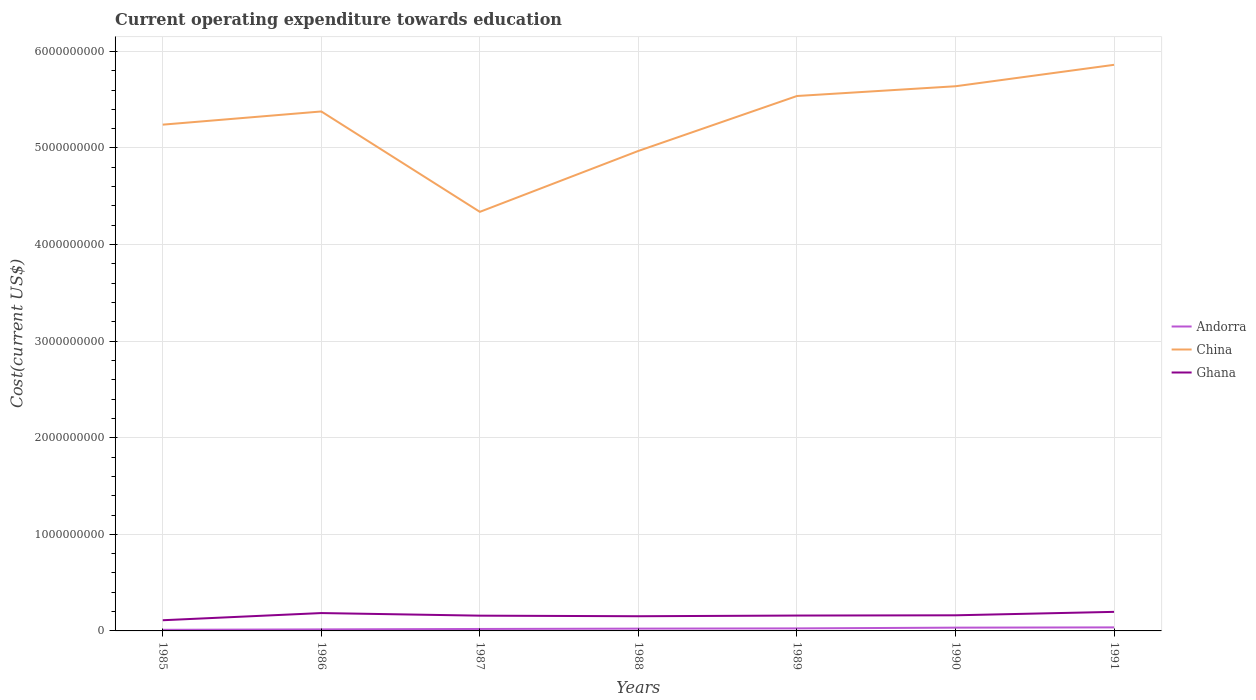Across all years, what is the maximum expenditure towards education in Ghana?
Your answer should be compact. 1.11e+08. What is the total expenditure towards education in Ghana in the graph?
Your answer should be very brief. -7.15e+06. What is the difference between the highest and the second highest expenditure towards education in China?
Make the answer very short. 1.52e+09. What is the difference between the highest and the lowest expenditure towards education in Andorra?
Your answer should be very brief. 3. How many lines are there?
Offer a terse response. 3. How many years are there in the graph?
Give a very brief answer. 7. What is the difference between two consecutive major ticks on the Y-axis?
Your answer should be compact. 1.00e+09. Are the values on the major ticks of Y-axis written in scientific E-notation?
Make the answer very short. No. Does the graph contain grids?
Your answer should be compact. Yes. Where does the legend appear in the graph?
Provide a short and direct response. Center right. What is the title of the graph?
Give a very brief answer. Current operating expenditure towards education. What is the label or title of the X-axis?
Your answer should be very brief. Years. What is the label or title of the Y-axis?
Offer a terse response. Cost(current US$). What is the Cost(current US$) in Andorra in 1985?
Provide a short and direct response. 1.14e+07. What is the Cost(current US$) in China in 1985?
Offer a terse response. 5.24e+09. What is the Cost(current US$) in Ghana in 1985?
Make the answer very short. 1.11e+08. What is the Cost(current US$) of Andorra in 1986?
Your response must be concise. 1.59e+07. What is the Cost(current US$) in China in 1986?
Offer a very short reply. 5.38e+09. What is the Cost(current US$) in Ghana in 1986?
Your response must be concise. 1.85e+08. What is the Cost(current US$) in Andorra in 1987?
Ensure brevity in your answer.  2.02e+07. What is the Cost(current US$) in China in 1987?
Your response must be concise. 4.34e+09. What is the Cost(current US$) of Ghana in 1987?
Make the answer very short. 1.58e+08. What is the Cost(current US$) in Andorra in 1988?
Provide a succinct answer. 2.38e+07. What is the Cost(current US$) of China in 1988?
Your answer should be compact. 4.97e+09. What is the Cost(current US$) of Ghana in 1988?
Provide a short and direct response. 1.52e+08. What is the Cost(current US$) in Andorra in 1989?
Your answer should be very brief. 2.63e+07. What is the Cost(current US$) of China in 1989?
Make the answer very short. 5.54e+09. What is the Cost(current US$) of Ghana in 1989?
Keep it short and to the point. 1.59e+08. What is the Cost(current US$) in Andorra in 1990?
Provide a short and direct response. 3.40e+07. What is the Cost(current US$) in China in 1990?
Your answer should be very brief. 5.64e+09. What is the Cost(current US$) in Ghana in 1990?
Offer a very short reply. 1.62e+08. What is the Cost(current US$) of Andorra in 1991?
Your answer should be very brief. 3.65e+07. What is the Cost(current US$) in China in 1991?
Provide a short and direct response. 5.86e+09. What is the Cost(current US$) of Ghana in 1991?
Provide a succinct answer. 1.97e+08. Across all years, what is the maximum Cost(current US$) in Andorra?
Give a very brief answer. 3.65e+07. Across all years, what is the maximum Cost(current US$) of China?
Offer a very short reply. 5.86e+09. Across all years, what is the maximum Cost(current US$) of Ghana?
Ensure brevity in your answer.  1.97e+08. Across all years, what is the minimum Cost(current US$) in Andorra?
Your response must be concise. 1.14e+07. Across all years, what is the minimum Cost(current US$) of China?
Your response must be concise. 4.34e+09. Across all years, what is the minimum Cost(current US$) in Ghana?
Provide a short and direct response. 1.11e+08. What is the total Cost(current US$) in Andorra in the graph?
Give a very brief answer. 1.68e+08. What is the total Cost(current US$) in China in the graph?
Make the answer very short. 3.70e+1. What is the total Cost(current US$) of Ghana in the graph?
Provide a short and direct response. 1.12e+09. What is the difference between the Cost(current US$) in Andorra in 1985 and that in 1986?
Provide a succinct answer. -4.46e+06. What is the difference between the Cost(current US$) in China in 1985 and that in 1986?
Your response must be concise. -1.37e+08. What is the difference between the Cost(current US$) of Ghana in 1985 and that in 1986?
Ensure brevity in your answer.  -7.42e+07. What is the difference between the Cost(current US$) in Andorra in 1985 and that in 1987?
Give a very brief answer. -8.73e+06. What is the difference between the Cost(current US$) of China in 1985 and that in 1987?
Ensure brevity in your answer.  9.03e+08. What is the difference between the Cost(current US$) of Ghana in 1985 and that in 1987?
Provide a short and direct response. -4.74e+07. What is the difference between the Cost(current US$) of Andorra in 1985 and that in 1988?
Provide a short and direct response. -1.24e+07. What is the difference between the Cost(current US$) of China in 1985 and that in 1988?
Provide a short and direct response. 2.72e+08. What is the difference between the Cost(current US$) in Ghana in 1985 and that in 1988?
Ensure brevity in your answer.  -4.14e+07. What is the difference between the Cost(current US$) of Andorra in 1985 and that in 1989?
Your response must be concise. -1.48e+07. What is the difference between the Cost(current US$) of China in 1985 and that in 1989?
Keep it short and to the point. -2.97e+08. What is the difference between the Cost(current US$) in Ghana in 1985 and that in 1989?
Give a very brief answer. -4.85e+07. What is the difference between the Cost(current US$) in Andorra in 1985 and that in 1990?
Give a very brief answer. -2.25e+07. What is the difference between the Cost(current US$) in China in 1985 and that in 1990?
Ensure brevity in your answer.  -3.98e+08. What is the difference between the Cost(current US$) of Ghana in 1985 and that in 1990?
Provide a succinct answer. -5.11e+07. What is the difference between the Cost(current US$) in Andorra in 1985 and that in 1991?
Your answer should be very brief. -2.51e+07. What is the difference between the Cost(current US$) of China in 1985 and that in 1991?
Keep it short and to the point. -6.19e+08. What is the difference between the Cost(current US$) of Ghana in 1985 and that in 1991?
Offer a terse response. -8.68e+07. What is the difference between the Cost(current US$) of Andorra in 1986 and that in 1987?
Provide a succinct answer. -4.27e+06. What is the difference between the Cost(current US$) in China in 1986 and that in 1987?
Make the answer very short. 1.04e+09. What is the difference between the Cost(current US$) of Ghana in 1986 and that in 1987?
Ensure brevity in your answer.  2.69e+07. What is the difference between the Cost(current US$) of Andorra in 1986 and that in 1988?
Your answer should be compact. -7.90e+06. What is the difference between the Cost(current US$) of China in 1986 and that in 1988?
Ensure brevity in your answer.  4.09e+08. What is the difference between the Cost(current US$) in Ghana in 1986 and that in 1988?
Ensure brevity in your answer.  3.28e+07. What is the difference between the Cost(current US$) of Andorra in 1986 and that in 1989?
Offer a very short reply. -1.03e+07. What is the difference between the Cost(current US$) in China in 1986 and that in 1989?
Offer a terse response. -1.60e+08. What is the difference between the Cost(current US$) of Ghana in 1986 and that in 1989?
Ensure brevity in your answer.  2.57e+07. What is the difference between the Cost(current US$) of Andorra in 1986 and that in 1990?
Make the answer very short. -1.81e+07. What is the difference between the Cost(current US$) in China in 1986 and that in 1990?
Your answer should be compact. -2.61e+08. What is the difference between the Cost(current US$) of Ghana in 1986 and that in 1990?
Make the answer very short. 2.31e+07. What is the difference between the Cost(current US$) in Andorra in 1986 and that in 1991?
Keep it short and to the point. -2.06e+07. What is the difference between the Cost(current US$) of China in 1986 and that in 1991?
Offer a terse response. -4.83e+08. What is the difference between the Cost(current US$) of Ghana in 1986 and that in 1991?
Ensure brevity in your answer.  -1.25e+07. What is the difference between the Cost(current US$) in Andorra in 1987 and that in 1988?
Your answer should be very brief. -3.63e+06. What is the difference between the Cost(current US$) in China in 1987 and that in 1988?
Your answer should be compact. -6.31e+08. What is the difference between the Cost(current US$) of Ghana in 1987 and that in 1988?
Give a very brief answer. 5.98e+06. What is the difference between the Cost(current US$) in Andorra in 1987 and that in 1989?
Your answer should be very brief. -6.08e+06. What is the difference between the Cost(current US$) in China in 1987 and that in 1989?
Your answer should be very brief. -1.20e+09. What is the difference between the Cost(current US$) in Ghana in 1987 and that in 1989?
Give a very brief answer. -1.17e+06. What is the difference between the Cost(current US$) in Andorra in 1987 and that in 1990?
Keep it short and to the point. -1.38e+07. What is the difference between the Cost(current US$) in China in 1987 and that in 1990?
Make the answer very short. -1.30e+09. What is the difference between the Cost(current US$) in Ghana in 1987 and that in 1990?
Offer a very short reply. -3.77e+06. What is the difference between the Cost(current US$) in Andorra in 1987 and that in 1991?
Ensure brevity in your answer.  -1.64e+07. What is the difference between the Cost(current US$) in China in 1987 and that in 1991?
Keep it short and to the point. -1.52e+09. What is the difference between the Cost(current US$) of Ghana in 1987 and that in 1991?
Provide a succinct answer. -3.94e+07. What is the difference between the Cost(current US$) of Andorra in 1988 and that in 1989?
Your answer should be compact. -2.44e+06. What is the difference between the Cost(current US$) of China in 1988 and that in 1989?
Make the answer very short. -5.69e+08. What is the difference between the Cost(current US$) of Ghana in 1988 and that in 1989?
Your answer should be very brief. -7.15e+06. What is the difference between the Cost(current US$) of Andorra in 1988 and that in 1990?
Your answer should be compact. -1.01e+07. What is the difference between the Cost(current US$) in China in 1988 and that in 1990?
Ensure brevity in your answer.  -6.69e+08. What is the difference between the Cost(current US$) in Ghana in 1988 and that in 1990?
Give a very brief answer. -9.75e+06. What is the difference between the Cost(current US$) of Andorra in 1988 and that in 1991?
Offer a terse response. -1.27e+07. What is the difference between the Cost(current US$) in China in 1988 and that in 1991?
Offer a very short reply. -8.91e+08. What is the difference between the Cost(current US$) in Ghana in 1988 and that in 1991?
Offer a very short reply. -4.54e+07. What is the difference between the Cost(current US$) of Andorra in 1989 and that in 1990?
Your response must be concise. -7.71e+06. What is the difference between the Cost(current US$) of China in 1989 and that in 1990?
Provide a succinct answer. -1.01e+08. What is the difference between the Cost(current US$) in Ghana in 1989 and that in 1990?
Ensure brevity in your answer.  -2.60e+06. What is the difference between the Cost(current US$) of Andorra in 1989 and that in 1991?
Offer a very short reply. -1.03e+07. What is the difference between the Cost(current US$) in China in 1989 and that in 1991?
Your response must be concise. -3.23e+08. What is the difference between the Cost(current US$) in Ghana in 1989 and that in 1991?
Offer a very short reply. -3.82e+07. What is the difference between the Cost(current US$) in Andorra in 1990 and that in 1991?
Give a very brief answer. -2.57e+06. What is the difference between the Cost(current US$) of China in 1990 and that in 1991?
Provide a succinct answer. -2.22e+08. What is the difference between the Cost(current US$) in Ghana in 1990 and that in 1991?
Your response must be concise. -3.56e+07. What is the difference between the Cost(current US$) of Andorra in 1985 and the Cost(current US$) of China in 1986?
Give a very brief answer. -5.37e+09. What is the difference between the Cost(current US$) in Andorra in 1985 and the Cost(current US$) in Ghana in 1986?
Keep it short and to the point. -1.73e+08. What is the difference between the Cost(current US$) of China in 1985 and the Cost(current US$) of Ghana in 1986?
Your answer should be compact. 5.06e+09. What is the difference between the Cost(current US$) in Andorra in 1985 and the Cost(current US$) in China in 1987?
Offer a terse response. -4.33e+09. What is the difference between the Cost(current US$) in Andorra in 1985 and the Cost(current US$) in Ghana in 1987?
Keep it short and to the point. -1.47e+08. What is the difference between the Cost(current US$) in China in 1985 and the Cost(current US$) in Ghana in 1987?
Provide a short and direct response. 5.08e+09. What is the difference between the Cost(current US$) in Andorra in 1985 and the Cost(current US$) in China in 1988?
Ensure brevity in your answer.  -4.96e+09. What is the difference between the Cost(current US$) in Andorra in 1985 and the Cost(current US$) in Ghana in 1988?
Your response must be concise. -1.41e+08. What is the difference between the Cost(current US$) of China in 1985 and the Cost(current US$) of Ghana in 1988?
Provide a short and direct response. 5.09e+09. What is the difference between the Cost(current US$) in Andorra in 1985 and the Cost(current US$) in China in 1989?
Keep it short and to the point. -5.53e+09. What is the difference between the Cost(current US$) of Andorra in 1985 and the Cost(current US$) of Ghana in 1989?
Provide a succinct answer. -1.48e+08. What is the difference between the Cost(current US$) of China in 1985 and the Cost(current US$) of Ghana in 1989?
Provide a short and direct response. 5.08e+09. What is the difference between the Cost(current US$) in Andorra in 1985 and the Cost(current US$) in China in 1990?
Give a very brief answer. -5.63e+09. What is the difference between the Cost(current US$) of Andorra in 1985 and the Cost(current US$) of Ghana in 1990?
Your answer should be compact. -1.50e+08. What is the difference between the Cost(current US$) of China in 1985 and the Cost(current US$) of Ghana in 1990?
Provide a short and direct response. 5.08e+09. What is the difference between the Cost(current US$) of Andorra in 1985 and the Cost(current US$) of China in 1991?
Give a very brief answer. -5.85e+09. What is the difference between the Cost(current US$) in Andorra in 1985 and the Cost(current US$) in Ghana in 1991?
Make the answer very short. -1.86e+08. What is the difference between the Cost(current US$) of China in 1985 and the Cost(current US$) of Ghana in 1991?
Ensure brevity in your answer.  5.04e+09. What is the difference between the Cost(current US$) in Andorra in 1986 and the Cost(current US$) in China in 1987?
Your answer should be very brief. -4.32e+09. What is the difference between the Cost(current US$) of Andorra in 1986 and the Cost(current US$) of Ghana in 1987?
Your answer should be very brief. -1.42e+08. What is the difference between the Cost(current US$) in China in 1986 and the Cost(current US$) in Ghana in 1987?
Provide a succinct answer. 5.22e+09. What is the difference between the Cost(current US$) in Andorra in 1986 and the Cost(current US$) in China in 1988?
Your answer should be compact. -4.95e+09. What is the difference between the Cost(current US$) of Andorra in 1986 and the Cost(current US$) of Ghana in 1988?
Offer a very short reply. -1.36e+08. What is the difference between the Cost(current US$) in China in 1986 and the Cost(current US$) in Ghana in 1988?
Your response must be concise. 5.23e+09. What is the difference between the Cost(current US$) of Andorra in 1986 and the Cost(current US$) of China in 1989?
Provide a succinct answer. -5.52e+09. What is the difference between the Cost(current US$) of Andorra in 1986 and the Cost(current US$) of Ghana in 1989?
Provide a short and direct response. -1.43e+08. What is the difference between the Cost(current US$) of China in 1986 and the Cost(current US$) of Ghana in 1989?
Ensure brevity in your answer.  5.22e+09. What is the difference between the Cost(current US$) of Andorra in 1986 and the Cost(current US$) of China in 1990?
Offer a very short reply. -5.62e+09. What is the difference between the Cost(current US$) of Andorra in 1986 and the Cost(current US$) of Ghana in 1990?
Provide a succinct answer. -1.46e+08. What is the difference between the Cost(current US$) of China in 1986 and the Cost(current US$) of Ghana in 1990?
Offer a very short reply. 5.22e+09. What is the difference between the Cost(current US$) of Andorra in 1986 and the Cost(current US$) of China in 1991?
Your answer should be compact. -5.85e+09. What is the difference between the Cost(current US$) in Andorra in 1986 and the Cost(current US$) in Ghana in 1991?
Your response must be concise. -1.81e+08. What is the difference between the Cost(current US$) of China in 1986 and the Cost(current US$) of Ghana in 1991?
Offer a very short reply. 5.18e+09. What is the difference between the Cost(current US$) of Andorra in 1987 and the Cost(current US$) of China in 1988?
Offer a very short reply. -4.95e+09. What is the difference between the Cost(current US$) in Andorra in 1987 and the Cost(current US$) in Ghana in 1988?
Offer a very short reply. -1.32e+08. What is the difference between the Cost(current US$) of China in 1987 and the Cost(current US$) of Ghana in 1988?
Offer a very short reply. 4.19e+09. What is the difference between the Cost(current US$) of Andorra in 1987 and the Cost(current US$) of China in 1989?
Give a very brief answer. -5.52e+09. What is the difference between the Cost(current US$) in Andorra in 1987 and the Cost(current US$) in Ghana in 1989?
Offer a terse response. -1.39e+08. What is the difference between the Cost(current US$) in China in 1987 and the Cost(current US$) in Ghana in 1989?
Provide a short and direct response. 4.18e+09. What is the difference between the Cost(current US$) in Andorra in 1987 and the Cost(current US$) in China in 1990?
Your answer should be compact. -5.62e+09. What is the difference between the Cost(current US$) of Andorra in 1987 and the Cost(current US$) of Ghana in 1990?
Your answer should be compact. -1.42e+08. What is the difference between the Cost(current US$) of China in 1987 and the Cost(current US$) of Ghana in 1990?
Your answer should be very brief. 4.18e+09. What is the difference between the Cost(current US$) in Andorra in 1987 and the Cost(current US$) in China in 1991?
Your answer should be compact. -5.84e+09. What is the difference between the Cost(current US$) in Andorra in 1987 and the Cost(current US$) in Ghana in 1991?
Give a very brief answer. -1.77e+08. What is the difference between the Cost(current US$) in China in 1987 and the Cost(current US$) in Ghana in 1991?
Make the answer very short. 4.14e+09. What is the difference between the Cost(current US$) of Andorra in 1988 and the Cost(current US$) of China in 1989?
Keep it short and to the point. -5.51e+09. What is the difference between the Cost(current US$) of Andorra in 1988 and the Cost(current US$) of Ghana in 1989?
Keep it short and to the point. -1.35e+08. What is the difference between the Cost(current US$) in China in 1988 and the Cost(current US$) in Ghana in 1989?
Give a very brief answer. 4.81e+09. What is the difference between the Cost(current US$) in Andorra in 1988 and the Cost(current US$) in China in 1990?
Your answer should be compact. -5.62e+09. What is the difference between the Cost(current US$) of Andorra in 1988 and the Cost(current US$) of Ghana in 1990?
Give a very brief answer. -1.38e+08. What is the difference between the Cost(current US$) of China in 1988 and the Cost(current US$) of Ghana in 1990?
Ensure brevity in your answer.  4.81e+09. What is the difference between the Cost(current US$) of Andorra in 1988 and the Cost(current US$) of China in 1991?
Keep it short and to the point. -5.84e+09. What is the difference between the Cost(current US$) in Andorra in 1988 and the Cost(current US$) in Ghana in 1991?
Provide a short and direct response. -1.74e+08. What is the difference between the Cost(current US$) in China in 1988 and the Cost(current US$) in Ghana in 1991?
Provide a succinct answer. 4.77e+09. What is the difference between the Cost(current US$) of Andorra in 1989 and the Cost(current US$) of China in 1990?
Offer a very short reply. -5.61e+09. What is the difference between the Cost(current US$) in Andorra in 1989 and the Cost(current US$) in Ghana in 1990?
Provide a short and direct response. -1.35e+08. What is the difference between the Cost(current US$) in China in 1989 and the Cost(current US$) in Ghana in 1990?
Provide a succinct answer. 5.38e+09. What is the difference between the Cost(current US$) in Andorra in 1989 and the Cost(current US$) in China in 1991?
Your answer should be compact. -5.83e+09. What is the difference between the Cost(current US$) of Andorra in 1989 and the Cost(current US$) of Ghana in 1991?
Offer a very short reply. -1.71e+08. What is the difference between the Cost(current US$) in China in 1989 and the Cost(current US$) in Ghana in 1991?
Provide a succinct answer. 5.34e+09. What is the difference between the Cost(current US$) of Andorra in 1990 and the Cost(current US$) of China in 1991?
Offer a terse response. -5.83e+09. What is the difference between the Cost(current US$) in Andorra in 1990 and the Cost(current US$) in Ghana in 1991?
Ensure brevity in your answer.  -1.63e+08. What is the difference between the Cost(current US$) of China in 1990 and the Cost(current US$) of Ghana in 1991?
Make the answer very short. 5.44e+09. What is the average Cost(current US$) in Andorra per year?
Make the answer very short. 2.40e+07. What is the average Cost(current US$) in China per year?
Your answer should be compact. 5.28e+09. What is the average Cost(current US$) in Ghana per year?
Your answer should be very brief. 1.61e+08. In the year 1985, what is the difference between the Cost(current US$) in Andorra and Cost(current US$) in China?
Keep it short and to the point. -5.23e+09. In the year 1985, what is the difference between the Cost(current US$) in Andorra and Cost(current US$) in Ghana?
Ensure brevity in your answer.  -9.92e+07. In the year 1985, what is the difference between the Cost(current US$) in China and Cost(current US$) in Ghana?
Your answer should be very brief. 5.13e+09. In the year 1986, what is the difference between the Cost(current US$) of Andorra and Cost(current US$) of China?
Provide a short and direct response. -5.36e+09. In the year 1986, what is the difference between the Cost(current US$) in Andorra and Cost(current US$) in Ghana?
Keep it short and to the point. -1.69e+08. In the year 1986, what is the difference between the Cost(current US$) in China and Cost(current US$) in Ghana?
Ensure brevity in your answer.  5.19e+09. In the year 1987, what is the difference between the Cost(current US$) of Andorra and Cost(current US$) of China?
Provide a succinct answer. -4.32e+09. In the year 1987, what is the difference between the Cost(current US$) of Andorra and Cost(current US$) of Ghana?
Make the answer very short. -1.38e+08. In the year 1987, what is the difference between the Cost(current US$) in China and Cost(current US$) in Ghana?
Your answer should be compact. 4.18e+09. In the year 1988, what is the difference between the Cost(current US$) in Andorra and Cost(current US$) in China?
Your response must be concise. -4.95e+09. In the year 1988, what is the difference between the Cost(current US$) in Andorra and Cost(current US$) in Ghana?
Ensure brevity in your answer.  -1.28e+08. In the year 1988, what is the difference between the Cost(current US$) of China and Cost(current US$) of Ghana?
Give a very brief answer. 4.82e+09. In the year 1989, what is the difference between the Cost(current US$) of Andorra and Cost(current US$) of China?
Ensure brevity in your answer.  -5.51e+09. In the year 1989, what is the difference between the Cost(current US$) of Andorra and Cost(current US$) of Ghana?
Offer a very short reply. -1.33e+08. In the year 1989, what is the difference between the Cost(current US$) of China and Cost(current US$) of Ghana?
Your answer should be compact. 5.38e+09. In the year 1990, what is the difference between the Cost(current US$) of Andorra and Cost(current US$) of China?
Your response must be concise. -5.61e+09. In the year 1990, what is the difference between the Cost(current US$) of Andorra and Cost(current US$) of Ghana?
Give a very brief answer. -1.28e+08. In the year 1990, what is the difference between the Cost(current US$) of China and Cost(current US$) of Ghana?
Your answer should be very brief. 5.48e+09. In the year 1991, what is the difference between the Cost(current US$) of Andorra and Cost(current US$) of China?
Your answer should be very brief. -5.82e+09. In the year 1991, what is the difference between the Cost(current US$) of Andorra and Cost(current US$) of Ghana?
Offer a very short reply. -1.61e+08. In the year 1991, what is the difference between the Cost(current US$) of China and Cost(current US$) of Ghana?
Provide a succinct answer. 5.66e+09. What is the ratio of the Cost(current US$) in Andorra in 1985 to that in 1986?
Offer a terse response. 0.72. What is the ratio of the Cost(current US$) of China in 1985 to that in 1986?
Provide a succinct answer. 0.97. What is the ratio of the Cost(current US$) of Ghana in 1985 to that in 1986?
Offer a terse response. 0.6. What is the ratio of the Cost(current US$) of Andorra in 1985 to that in 1987?
Give a very brief answer. 0.57. What is the ratio of the Cost(current US$) of China in 1985 to that in 1987?
Give a very brief answer. 1.21. What is the ratio of the Cost(current US$) in Ghana in 1985 to that in 1987?
Provide a succinct answer. 0.7. What is the ratio of the Cost(current US$) of Andorra in 1985 to that in 1988?
Offer a very short reply. 0.48. What is the ratio of the Cost(current US$) in China in 1985 to that in 1988?
Offer a terse response. 1.05. What is the ratio of the Cost(current US$) of Ghana in 1985 to that in 1988?
Keep it short and to the point. 0.73. What is the ratio of the Cost(current US$) of Andorra in 1985 to that in 1989?
Provide a short and direct response. 0.44. What is the ratio of the Cost(current US$) in China in 1985 to that in 1989?
Provide a succinct answer. 0.95. What is the ratio of the Cost(current US$) in Ghana in 1985 to that in 1989?
Your answer should be very brief. 0.7. What is the ratio of the Cost(current US$) of Andorra in 1985 to that in 1990?
Provide a short and direct response. 0.34. What is the ratio of the Cost(current US$) in China in 1985 to that in 1990?
Offer a very short reply. 0.93. What is the ratio of the Cost(current US$) of Ghana in 1985 to that in 1990?
Provide a short and direct response. 0.68. What is the ratio of the Cost(current US$) in Andorra in 1985 to that in 1991?
Keep it short and to the point. 0.31. What is the ratio of the Cost(current US$) of China in 1985 to that in 1991?
Make the answer very short. 0.89. What is the ratio of the Cost(current US$) of Ghana in 1985 to that in 1991?
Provide a short and direct response. 0.56. What is the ratio of the Cost(current US$) in Andorra in 1986 to that in 1987?
Offer a very short reply. 0.79. What is the ratio of the Cost(current US$) of China in 1986 to that in 1987?
Your answer should be compact. 1.24. What is the ratio of the Cost(current US$) in Ghana in 1986 to that in 1987?
Your response must be concise. 1.17. What is the ratio of the Cost(current US$) of Andorra in 1986 to that in 1988?
Give a very brief answer. 0.67. What is the ratio of the Cost(current US$) of China in 1986 to that in 1988?
Ensure brevity in your answer.  1.08. What is the ratio of the Cost(current US$) in Ghana in 1986 to that in 1988?
Your answer should be very brief. 1.22. What is the ratio of the Cost(current US$) of Andorra in 1986 to that in 1989?
Offer a very short reply. 0.61. What is the ratio of the Cost(current US$) in China in 1986 to that in 1989?
Your response must be concise. 0.97. What is the ratio of the Cost(current US$) of Ghana in 1986 to that in 1989?
Keep it short and to the point. 1.16. What is the ratio of the Cost(current US$) in Andorra in 1986 to that in 1990?
Give a very brief answer. 0.47. What is the ratio of the Cost(current US$) of China in 1986 to that in 1990?
Offer a terse response. 0.95. What is the ratio of the Cost(current US$) in Ghana in 1986 to that in 1990?
Your answer should be compact. 1.14. What is the ratio of the Cost(current US$) in Andorra in 1986 to that in 1991?
Offer a very short reply. 0.44. What is the ratio of the Cost(current US$) in China in 1986 to that in 1991?
Your response must be concise. 0.92. What is the ratio of the Cost(current US$) of Ghana in 1986 to that in 1991?
Give a very brief answer. 0.94. What is the ratio of the Cost(current US$) of Andorra in 1987 to that in 1988?
Your answer should be compact. 0.85. What is the ratio of the Cost(current US$) of China in 1987 to that in 1988?
Give a very brief answer. 0.87. What is the ratio of the Cost(current US$) of Ghana in 1987 to that in 1988?
Ensure brevity in your answer.  1.04. What is the ratio of the Cost(current US$) in Andorra in 1987 to that in 1989?
Give a very brief answer. 0.77. What is the ratio of the Cost(current US$) in China in 1987 to that in 1989?
Ensure brevity in your answer.  0.78. What is the ratio of the Cost(current US$) of Andorra in 1987 to that in 1990?
Ensure brevity in your answer.  0.59. What is the ratio of the Cost(current US$) in China in 1987 to that in 1990?
Make the answer very short. 0.77. What is the ratio of the Cost(current US$) of Ghana in 1987 to that in 1990?
Offer a terse response. 0.98. What is the ratio of the Cost(current US$) in Andorra in 1987 to that in 1991?
Offer a terse response. 0.55. What is the ratio of the Cost(current US$) of China in 1987 to that in 1991?
Offer a terse response. 0.74. What is the ratio of the Cost(current US$) of Ghana in 1987 to that in 1991?
Give a very brief answer. 0.8. What is the ratio of the Cost(current US$) in Andorra in 1988 to that in 1989?
Provide a succinct answer. 0.91. What is the ratio of the Cost(current US$) in China in 1988 to that in 1989?
Your answer should be compact. 0.9. What is the ratio of the Cost(current US$) of Ghana in 1988 to that in 1989?
Ensure brevity in your answer.  0.96. What is the ratio of the Cost(current US$) of Andorra in 1988 to that in 1990?
Give a very brief answer. 0.7. What is the ratio of the Cost(current US$) in China in 1988 to that in 1990?
Your response must be concise. 0.88. What is the ratio of the Cost(current US$) of Ghana in 1988 to that in 1990?
Offer a terse response. 0.94. What is the ratio of the Cost(current US$) in Andorra in 1988 to that in 1991?
Make the answer very short. 0.65. What is the ratio of the Cost(current US$) of China in 1988 to that in 1991?
Provide a succinct answer. 0.85. What is the ratio of the Cost(current US$) in Ghana in 1988 to that in 1991?
Your response must be concise. 0.77. What is the ratio of the Cost(current US$) of Andorra in 1989 to that in 1990?
Ensure brevity in your answer.  0.77. What is the ratio of the Cost(current US$) in China in 1989 to that in 1990?
Provide a succinct answer. 0.98. What is the ratio of the Cost(current US$) in Ghana in 1989 to that in 1990?
Offer a terse response. 0.98. What is the ratio of the Cost(current US$) of Andorra in 1989 to that in 1991?
Provide a short and direct response. 0.72. What is the ratio of the Cost(current US$) of China in 1989 to that in 1991?
Make the answer very short. 0.94. What is the ratio of the Cost(current US$) in Ghana in 1989 to that in 1991?
Provide a short and direct response. 0.81. What is the ratio of the Cost(current US$) of Andorra in 1990 to that in 1991?
Your response must be concise. 0.93. What is the ratio of the Cost(current US$) in China in 1990 to that in 1991?
Your answer should be compact. 0.96. What is the ratio of the Cost(current US$) of Ghana in 1990 to that in 1991?
Provide a succinct answer. 0.82. What is the difference between the highest and the second highest Cost(current US$) of Andorra?
Your answer should be very brief. 2.57e+06. What is the difference between the highest and the second highest Cost(current US$) in China?
Your response must be concise. 2.22e+08. What is the difference between the highest and the second highest Cost(current US$) in Ghana?
Keep it short and to the point. 1.25e+07. What is the difference between the highest and the lowest Cost(current US$) of Andorra?
Give a very brief answer. 2.51e+07. What is the difference between the highest and the lowest Cost(current US$) in China?
Your answer should be compact. 1.52e+09. What is the difference between the highest and the lowest Cost(current US$) of Ghana?
Keep it short and to the point. 8.68e+07. 